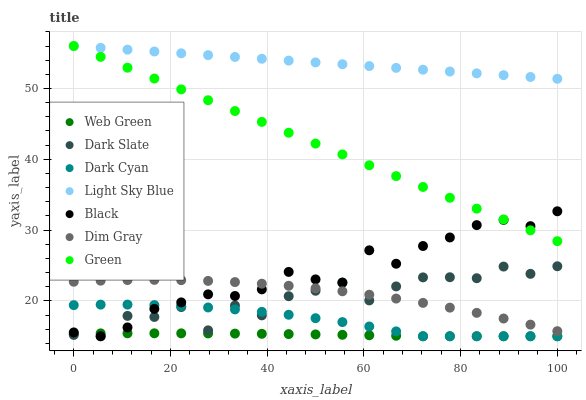Does Web Green have the minimum area under the curve?
Answer yes or no. Yes. Does Light Sky Blue have the maximum area under the curve?
Answer yes or no. Yes. Does Dark Slate have the minimum area under the curve?
Answer yes or no. No. Does Dark Slate have the maximum area under the curve?
Answer yes or no. No. Is Light Sky Blue the smoothest?
Answer yes or no. Yes. Is Dark Slate the roughest?
Answer yes or no. Yes. Is Web Green the smoothest?
Answer yes or no. No. Is Web Green the roughest?
Answer yes or no. No. Does Web Green have the lowest value?
Answer yes or no. Yes. Does Light Sky Blue have the lowest value?
Answer yes or no. No. Does Green have the highest value?
Answer yes or no. Yes. Does Dark Slate have the highest value?
Answer yes or no. No. Is Dark Slate less than Light Sky Blue?
Answer yes or no. Yes. Is Light Sky Blue greater than Dark Slate?
Answer yes or no. Yes. Does Web Green intersect Dark Cyan?
Answer yes or no. Yes. Is Web Green less than Dark Cyan?
Answer yes or no. No. Is Web Green greater than Dark Cyan?
Answer yes or no. No. Does Dark Slate intersect Light Sky Blue?
Answer yes or no. No. 